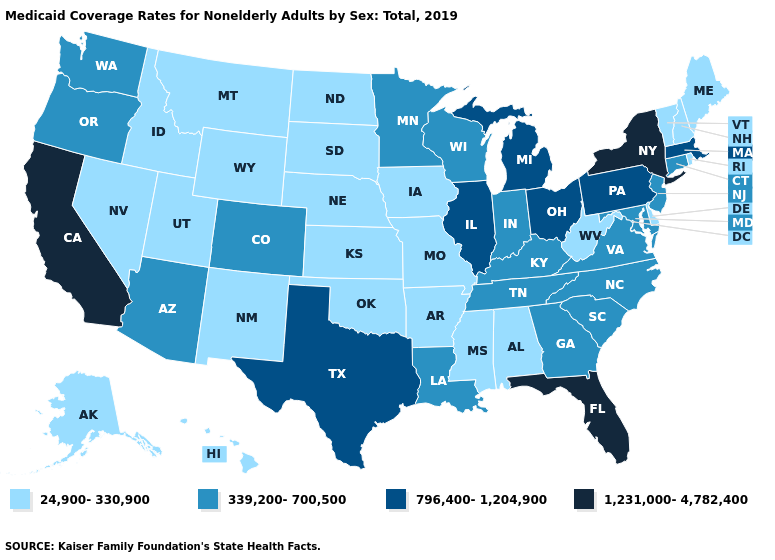Does Florida have the highest value in the USA?
Be succinct. Yes. Among the states that border Missouri , does Tennessee have the lowest value?
Quick response, please. No. Does Wisconsin have the lowest value in the MidWest?
Quick response, please. No. Does Connecticut have the lowest value in the Northeast?
Short answer required. No. Name the states that have a value in the range 1,231,000-4,782,400?
Keep it brief. California, Florida, New York. Is the legend a continuous bar?
Short answer required. No. Does Michigan have the lowest value in the USA?
Be succinct. No. Name the states that have a value in the range 1,231,000-4,782,400?
Concise answer only. California, Florida, New York. Name the states that have a value in the range 1,231,000-4,782,400?
Write a very short answer. California, Florida, New York. Name the states that have a value in the range 796,400-1,204,900?
Answer briefly. Illinois, Massachusetts, Michigan, Ohio, Pennsylvania, Texas. Name the states that have a value in the range 24,900-330,900?
Be succinct. Alabama, Alaska, Arkansas, Delaware, Hawaii, Idaho, Iowa, Kansas, Maine, Mississippi, Missouri, Montana, Nebraska, Nevada, New Hampshire, New Mexico, North Dakota, Oklahoma, Rhode Island, South Dakota, Utah, Vermont, West Virginia, Wyoming. Does Iowa have the lowest value in the MidWest?
Concise answer only. Yes. Name the states that have a value in the range 1,231,000-4,782,400?
Answer briefly. California, Florida, New York. Among the states that border North Carolina , which have the lowest value?
Keep it brief. Georgia, South Carolina, Tennessee, Virginia. Among the states that border Illinois , does Iowa have the highest value?
Answer briefly. No. 